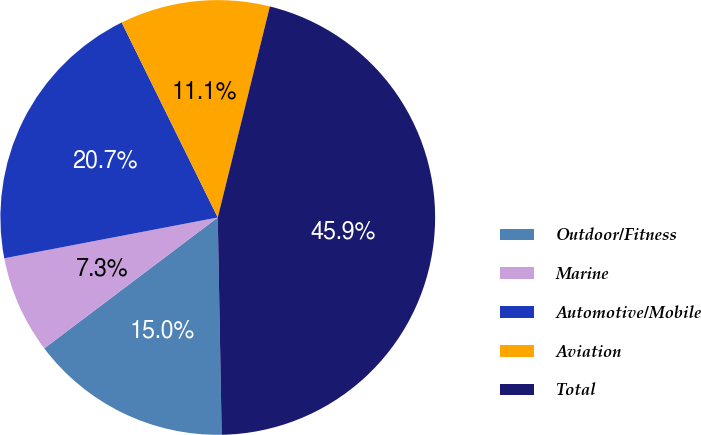<chart> <loc_0><loc_0><loc_500><loc_500><pie_chart><fcel>Outdoor/Fitness<fcel>Marine<fcel>Automotive/Mobile<fcel>Aviation<fcel>Total<nl><fcel>15.0%<fcel>7.28%<fcel>20.72%<fcel>11.14%<fcel>45.86%<nl></chart> 